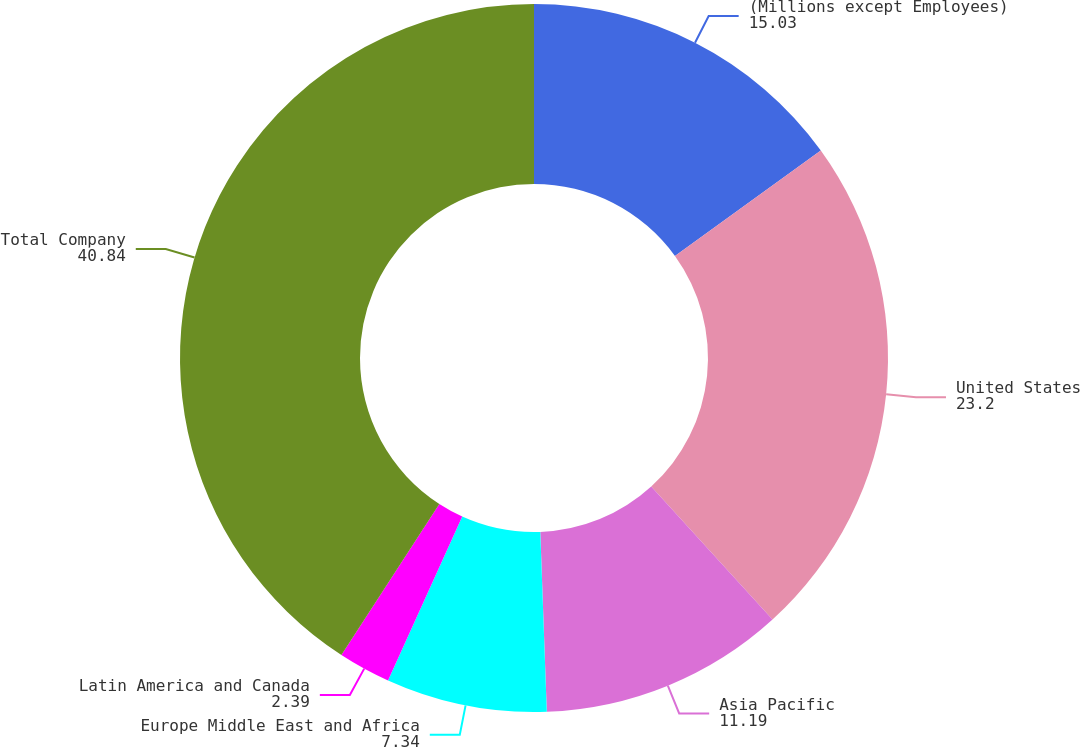Convert chart. <chart><loc_0><loc_0><loc_500><loc_500><pie_chart><fcel>(Millions except Employees)<fcel>United States<fcel>Asia Pacific<fcel>Europe Middle East and Africa<fcel>Latin America and Canada<fcel>Total Company<nl><fcel>15.03%<fcel>23.2%<fcel>11.19%<fcel>7.34%<fcel>2.39%<fcel>40.84%<nl></chart> 